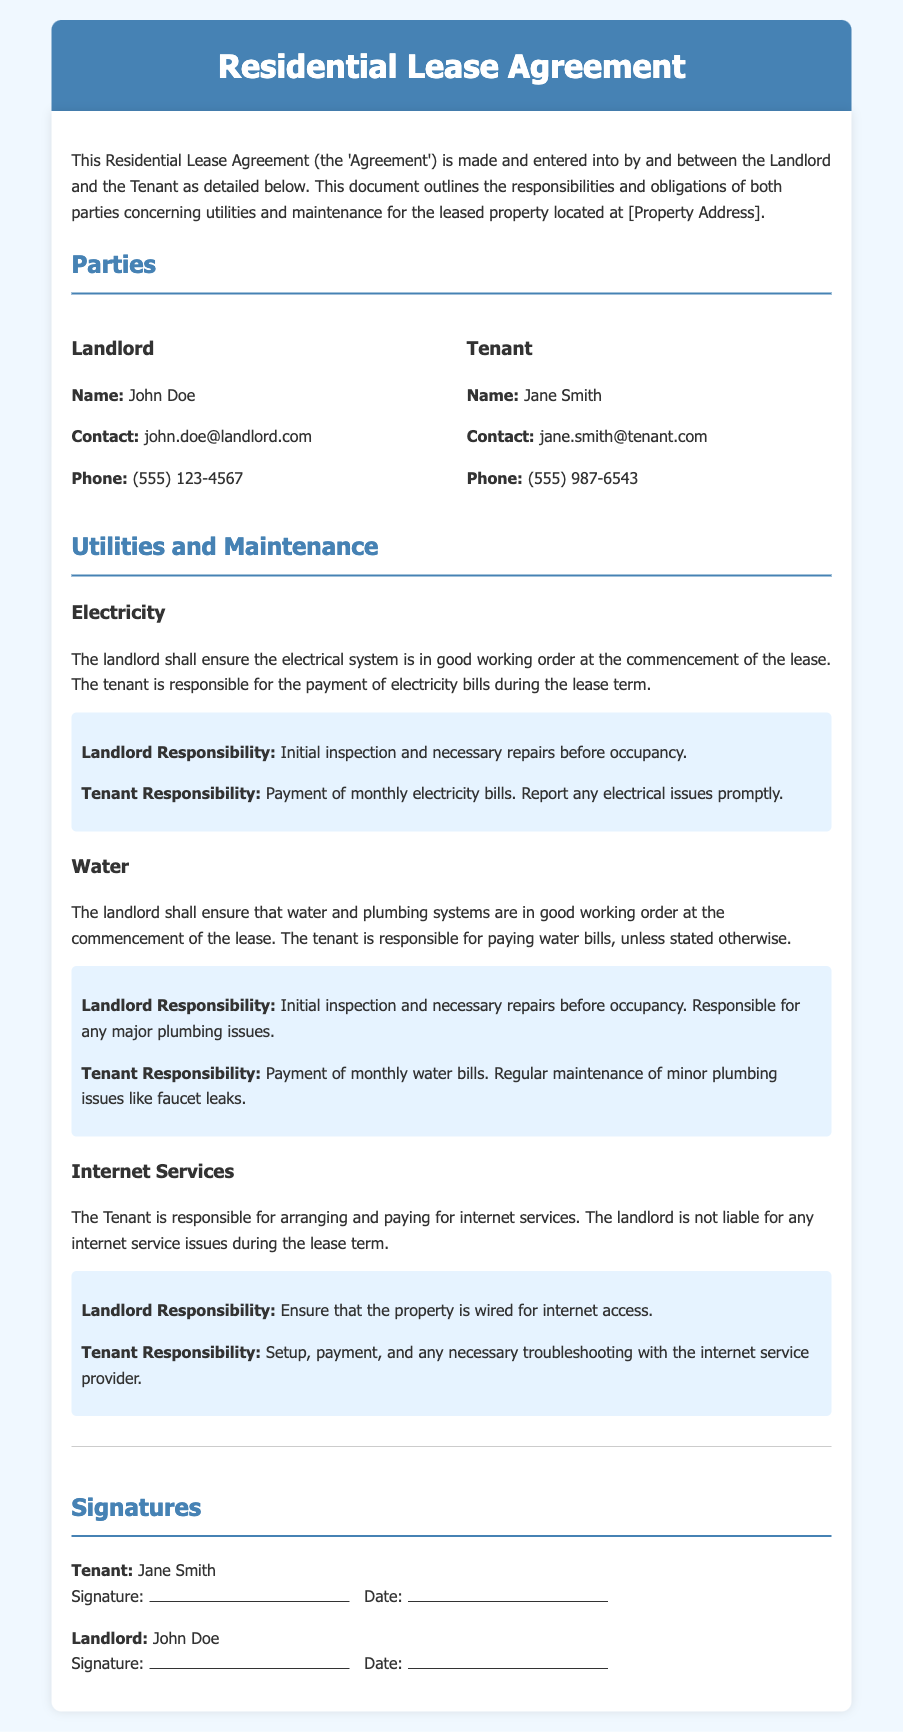What is the name of the landlord? The landlord's name is stated in the parties section of the document.
Answer: John Doe What is the tenant responsible for regarding electricity? The tenant's responsibilities regarding electricity are outlined in the electricity section.
Answer: Payment of monthly electricity bills Who is responsible for water bill payments? The document outlines the responsibilities related to water bills, which involves both parties.
Answer: Tenant What happens if there are major plumbing issues? The responsibilities for plumbing issues are specified in the water section of the document.
Answer: Landlord Is the landlord responsible for internet service problems? The document clarifies the responsibilities surrounding internet services, detailing landlord obligations.
Answer: No What is the tenant required to do if there are electrical issues? The tenant's responsibilities regarding electrical issues are explained in the electricity section.
Answer: Report any electrical issues promptly Who ensures the property is wired for internet access? The responsibilities regarding internet access are specified under internet services.
Answer: Landlord What is the tenant responsible for regarding internet services? The internet services section outlines the tenant's obligations specifically.
Answer: Setup, payment, and any necessary troubleshooting When is the electrical system condition verified? The initial condition of the electrical system is mentioned in the electricity section, indicating when this occurs.
Answer: At the commencement of the lease 